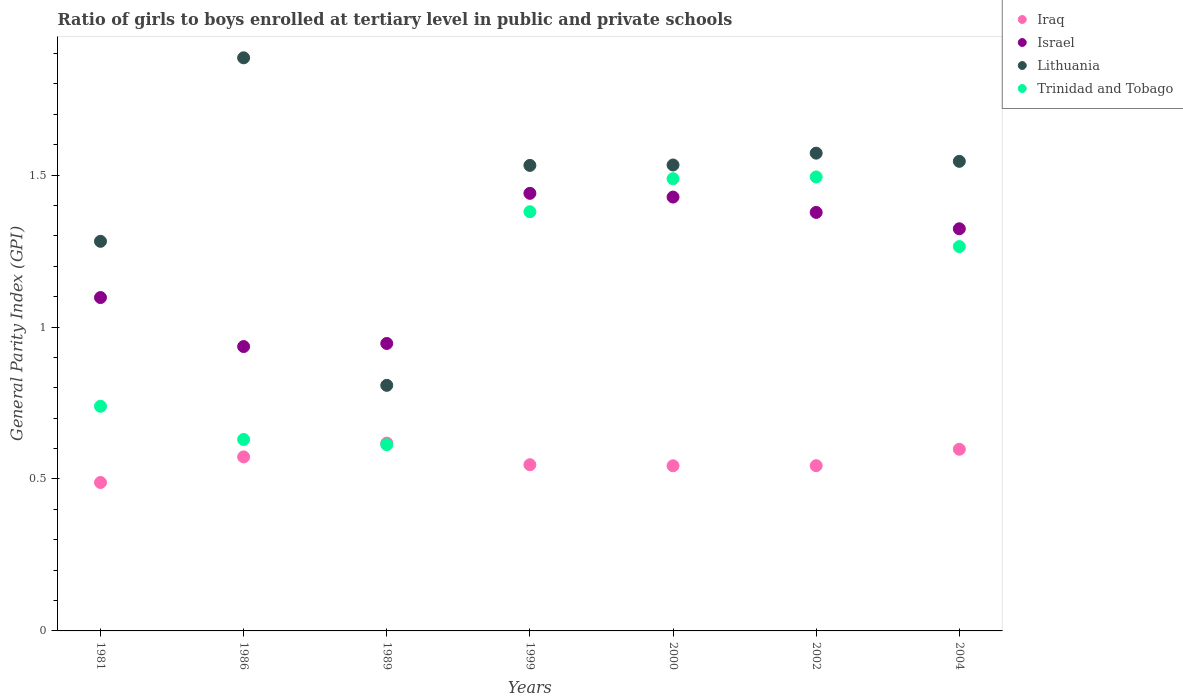What is the general parity index in Iraq in 2000?
Provide a succinct answer. 0.54. Across all years, what is the maximum general parity index in Lithuania?
Your answer should be very brief. 1.89. Across all years, what is the minimum general parity index in Trinidad and Tobago?
Your answer should be compact. 0.61. In which year was the general parity index in Trinidad and Tobago maximum?
Keep it short and to the point. 2002. What is the total general parity index in Iraq in the graph?
Keep it short and to the point. 3.91. What is the difference between the general parity index in Lithuania in 1981 and that in 2004?
Provide a short and direct response. -0.26. What is the difference between the general parity index in Israel in 2004 and the general parity index in Lithuania in 2000?
Keep it short and to the point. -0.21. What is the average general parity index in Trinidad and Tobago per year?
Provide a short and direct response. 1.09. In the year 1989, what is the difference between the general parity index in Trinidad and Tobago and general parity index in Iraq?
Keep it short and to the point. -0.01. What is the ratio of the general parity index in Israel in 2002 to that in 2004?
Your answer should be compact. 1.04. Is the general parity index in Iraq in 1999 less than that in 2002?
Offer a terse response. No. What is the difference between the highest and the second highest general parity index in Lithuania?
Give a very brief answer. 0.31. What is the difference between the highest and the lowest general parity index in Israel?
Give a very brief answer. 0.5. Is the sum of the general parity index in Lithuania in 1981 and 2000 greater than the maximum general parity index in Israel across all years?
Keep it short and to the point. Yes. Is it the case that in every year, the sum of the general parity index in Israel and general parity index in Lithuania  is greater than the general parity index in Trinidad and Tobago?
Your answer should be very brief. Yes. Is the general parity index in Iraq strictly greater than the general parity index in Lithuania over the years?
Provide a succinct answer. No. Is the general parity index in Iraq strictly less than the general parity index in Trinidad and Tobago over the years?
Give a very brief answer. No. What is the difference between two consecutive major ticks on the Y-axis?
Your answer should be very brief. 0.5. Does the graph contain any zero values?
Provide a succinct answer. No. Where does the legend appear in the graph?
Provide a succinct answer. Top right. How many legend labels are there?
Provide a succinct answer. 4. How are the legend labels stacked?
Give a very brief answer. Vertical. What is the title of the graph?
Make the answer very short. Ratio of girls to boys enrolled at tertiary level in public and private schools. Does "Channel Islands" appear as one of the legend labels in the graph?
Provide a succinct answer. No. What is the label or title of the X-axis?
Your answer should be very brief. Years. What is the label or title of the Y-axis?
Provide a short and direct response. General Parity Index (GPI). What is the General Parity Index (GPI) of Iraq in 1981?
Make the answer very short. 0.49. What is the General Parity Index (GPI) in Israel in 1981?
Give a very brief answer. 1.1. What is the General Parity Index (GPI) of Lithuania in 1981?
Offer a terse response. 1.28. What is the General Parity Index (GPI) in Trinidad and Tobago in 1981?
Keep it short and to the point. 0.74. What is the General Parity Index (GPI) of Iraq in 1986?
Offer a terse response. 0.57. What is the General Parity Index (GPI) of Israel in 1986?
Offer a terse response. 0.94. What is the General Parity Index (GPI) in Lithuania in 1986?
Keep it short and to the point. 1.89. What is the General Parity Index (GPI) in Trinidad and Tobago in 1986?
Offer a very short reply. 0.63. What is the General Parity Index (GPI) of Iraq in 1989?
Your response must be concise. 0.62. What is the General Parity Index (GPI) in Israel in 1989?
Make the answer very short. 0.95. What is the General Parity Index (GPI) of Lithuania in 1989?
Ensure brevity in your answer.  0.81. What is the General Parity Index (GPI) in Trinidad and Tobago in 1989?
Your answer should be very brief. 0.61. What is the General Parity Index (GPI) in Iraq in 1999?
Your answer should be very brief. 0.55. What is the General Parity Index (GPI) in Israel in 1999?
Your answer should be compact. 1.44. What is the General Parity Index (GPI) in Lithuania in 1999?
Provide a short and direct response. 1.53. What is the General Parity Index (GPI) in Trinidad and Tobago in 1999?
Your response must be concise. 1.38. What is the General Parity Index (GPI) in Iraq in 2000?
Provide a short and direct response. 0.54. What is the General Parity Index (GPI) in Israel in 2000?
Make the answer very short. 1.43. What is the General Parity Index (GPI) of Lithuania in 2000?
Offer a terse response. 1.53. What is the General Parity Index (GPI) of Trinidad and Tobago in 2000?
Ensure brevity in your answer.  1.49. What is the General Parity Index (GPI) in Iraq in 2002?
Provide a succinct answer. 0.54. What is the General Parity Index (GPI) in Israel in 2002?
Ensure brevity in your answer.  1.38. What is the General Parity Index (GPI) of Lithuania in 2002?
Give a very brief answer. 1.57. What is the General Parity Index (GPI) in Trinidad and Tobago in 2002?
Offer a very short reply. 1.49. What is the General Parity Index (GPI) in Iraq in 2004?
Your answer should be compact. 0.6. What is the General Parity Index (GPI) in Israel in 2004?
Your answer should be compact. 1.32. What is the General Parity Index (GPI) of Lithuania in 2004?
Give a very brief answer. 1.55. What is the General Parity Index (GPI) in Trinidad and Tobago in 2004?
Ensure brevity in your answer.  1.26. Across all years, what is the maximum General Parity Index (GPI) in Iraq?
Offer a terse response. 0.62. Across all years, what is the maximum General Parity Index (GPI) of Israel?
Your answer should be compact. 1.44. Across all years, what is the maximum General Parity Index (GPI) in Lithuania?
Your answer should be compact. 1.89. Across all years, what is the maximum General Parity Index (GPI) in Trinidad and Tobago?
Your response must be concise. 1.49. Across all years, what is the minimum General Parity Index (GPI) in Iraq?
Keep it short and to the point. 0.49. Across all years, what is the minimum General Parity Index (GPI) in Israel?
Your answer should be compact. 0.94. Across all years, what is the minimum General Parity Index (GPI) of Lithuania?
Your response must be concise. 0.81. Across all years, what is the minimum General Parity Index (GPI) in Trinidad and Tobago?
Give a very brief answer. 0.61. What is the total General Parity Index (GPI) in Iraq in the graph?
Your response must be concise. 3.91. What is the total General Parity Index (GPI) in Israel in the graph?
Give a very brief answer. 8.55. What is the total General Parity Index (GPI) of Lithuania in the graph?
Make the answer very short. 10.16. What is the total General Parity Index (GPI) of Trinidad and Tobago in the graph?
Give a very brief answer. 7.61. What is the difference between the General Parity Index (GPI) in Iraq in 1981 and that in 1986?
Your answer should be compact. -0.08. What is the difference between the General Parity Index (GPI) in Israel in 1981 and that in 1986?
Provide a succinct answer. 0.16. What is the difference between the General Parity Index (GPI) of Lithuania in 1981 and that in 1986?
Keep it short and to the point. -0.6. What is the difference between the General Parity Index (GPI) of Trinidad and Tobago in 1981 and that in 1986?
Your response must be concise. 0.11. What is the difference between the General Parity Index (GPI) of Iraq in 1981 and that in 1989?
Provide a short and direct response. -0.13. What is the difference between the General Parity Index (GPI) of Israel in 1981 and that in 1989?
Keep it short and to the point. 0.15. What is the difference between the General Parity Index (GPI) in Lithuania in 1981 and that in 1989?
Offer a terse response. 0.47. What is the difference between the General Parity Index (GPI) in Trinidad and Tobago in 1981 and that in 1989?
Give a very brief answer. 0.13. What is the difference between the General Parity Index (GPI) in Iraq in 1981 and that in 1999?
Your response must be concise. -0.06. What is the difference between the General Parity Index (GPI) of Israel in 1981 and that in 1999?
Offer a very short reply. -0.34. What is the difference between the General Parity Index (GPI) of Lithuania in 1981 and that in 1999?
Your response must be concise. -0.25. What is the difference between the General Parity Index (GPI) in Trinidad and Tobago in 1981 and that in 1999?
Make the answer very short. -0.64. What is the difference between the General Parity Index (GPI) of Iraq in 1981 and that in 2000?
Keep it short and to the point. -0.06. What is the difference between the General Parity Index (GPI) in Israel in 1981 and that in 2000?
Provide a succinct answer. -0.33. What is the difference between the General Parity Index (GPI) of Lithuania in 1981 and that in 2000?
Keep it short and to the point. -0.25. What is the difference between the General Parity Index (GPI) of Trinidad and Tobago in 1981 and that in 2000?
Your response must be concise. -0.75. What is the difference between the General Parity Index (GPI) of Iraq in 1981 and that in 2002?
Keep it short and to the point. -0.06. What is the difference between the General Parity Index (GPI) in Israel in 1981 and that in 2002?
Ensure brevity in your answer.  -0.28. What is the difference between the General Parity Index (GPI) in Lithuania in 1981 and that in 2002?
Offer a terse response. -0.29. What is the difference between the General Parity Index (GPI) of Trinidad and Tobago in 1981 and that in 2002?
Offer a very short reply. -0.75. What is the difference between the General Parity Index (GPI) in Iraq in 1981 and that in 2004?
Give a very brief answer. -0.11. What is the difference between the General Parity Index (GPI) in Israel in 1981 and that in 2004?
Give a very brief answer. -0.23. What is the difference between the General Parity Index (GPI) in Lithuania in 1981 and that in 2004?
Your answer should be compact. -0.26. What is the difference between the General Parity Index (GPI) of Trinidad and Tobago in 1981 and that in 2004?
Your answer should be very brief. -0.53. What is the difference between the General Parity Index (GPI) of Iraq in 1986 and that in 1989?
Provide a succinct answer. -0.05. What is the difference between the General Parity Index (GPI) of Israel in 1986 and that in 1989?
Ensure brevity in your answer.  -0.01. What is the difference between the General Parity Index (GPI) in Lithuania in 1986 and that in 1989?
Provide a short and direct response. 1.08. What is the difference between the General Parity Index (GPI) in Trinidad and Tobago in 1986 and that in 1989?
Your response must be concise. 0.02. What is the difference between the General Parity Index (GPI) of Iraq in 1986 and that in 1999?
Make the answer very short. 0.03. What is the difference between the General Parity Index (GPI) of Israel in 1986 and that in 1999?
Keep it short and to the point. -0.5. What is the difference between the General Parity Index (GPI) of Lithuania in 1986 and that in 1999?
Offer a terse response. 0.35. What is the difference between the General Parity Index (GPI) of Trinidad and Tobago in 1986 and that in 1999?
Offer a very short reply. -0.75. What is the difference between the General Parity Index (GPI) in Iraq in 1986 and that in 2000?
Give a very brief answer. 0.03. What is the difference between the General Parity Index (GPI) of Israel in 1986 and that in 2000?
Make the answer very short. -0.49. What is the difference between the General Parity Index (GPI) of Lithuania in 1986 and that in 2000?
Provide a short and direct response. 0.35. What is the difference between the General Parity Index (GPI) in Trinidad and Tobago in 1986 and that in 2000?
Your answer should be compact. -0.86. What is the difference between the General Parity Index (GPI) of Iraq in 1986 and that in 2002?
Your response must be concise. 0.03. What is the difference between the General Parity Index (GPI) of Israel in 1986 and that in 2002?
Make the answer very short. -0.44. What is the difference between the General Parity Index (GPI) in Lithuania in 1986 and that in 2002?
Give a very brief answer. 0.31. What is the difference between the General Parity Index (GPI) in Trinidad and Tobago in 1986 and that in 2002?
Offer a terse response. -0.86. What is the difference between the General Parity Index (GPI) of Iraq in 1986 and that in 2004?
Your answer should be very brief. -0.03. What is the difference between the General Parity Index (GPI) of Israel in 1986 and that in 2004?
Offer a terse response. -0.39. What is the difference between the General Parity Index (GPI) of Lithuania in 1986 and that in 2004?
Your response must be concise. 0.34. What is the difference between the General Parity Index (GPI) in Trinidad and Tobago in 1986 and that in 2004?
Ensure brevity in your answer.  -0.63. What is the difference between the General Parity Index (GPI) in Iraq in 1989 and that in 1999?
Your answer should be compact. 0.07. What is the difference between the General Parity Index (GPI) of Israel in 1989 and that in 1999?
Give a very brief answer. -0.49. What is the difference between the General Parity Index (GPI) of Lithuania in 1989 and that in 1999?
Your answer should be very brief. -0.72. What is the difference between the General Parity Index (GPI) in Trinidad and Tobago in 1989 and that in 1999?
Offer a very short reply. -0.77. What is the difference between the General Parity Index (GPI) of Iraq in 1989 and that in 2000?
Make the answer very short. 0.07. What is the difference between the General Parity Index (GPI) of Israel in 1989 and that in 2000?
Your answer should be compact. -0.48. What is the difference between the General Parity Index (GPI) in Lithuania in 1989 and that in 2000?
Your response must be concise. -0.72. What is the difference between the General Parity Index (GPI) of Trinidad and Tobago in 1989 and that in 2000?
Give a very brief answer. -0.88. What is the difference between the General Parity Index (GPI) of Iraq in 1989 and that in 2002?
Give a very brief answer. 0.07. What is the difference between the General Parity Index (GPI) in Israel in 1989 and that in 2002?
Ensure brevity in your answer.  -0.43. What is the difference between the General Parity Index (GPI) in Lithuania in 1989 and that in 2002?
Provide a succinct answer. -0.76. What is the difference between the General Parity Index (GPI) of Trinidad and Tobago in 1989 and that in 2002?
Give a very brief answer. -0.88. What is the difference between the General Parity Index (GPI) of Iraq in 1989 and that in 2004?
Provide a succinct answer. 0.02. What is the difference between the General Parity Index (GPI) of Israel in 1989 and that in 2004?
Keep it short and to the point. -0.38. What is the difference between the General Parity Index (GPI) of Lithuania in 1989 and that in 2004?
Your response must be concise. -0.74. What is the difference between the General Parity Index (GPI) of Trinidad and Tobago in 1989 and that in 2004?
Your response must be concise. -0.65. What is the difference between the General Parity Index (GPI) in Iraq in 1999 and that in 2000?
Provide a succinct answer. 0. What is the difference between the General Parity Index (GPI) of Israel in 1999 and that in 2000?
Offer a very short reply. 0.01. What is the difference between the General Parity Index (GPI) of Lithuania in 1999 and that in 2000?
Give a very brief answer. -0. What is the difference between the General Parity Index (GPI) in Trinidad and Tobago in 1999 and that in 2000?
Make the answer very short. -0.11. What is the difference between the General Parity Index (GPI) in Iraq in 1999 and that in 2002?
Your answer should be very brief. 0. What is the difference between the General Parity Index (GPI) of Israel in 1999 and that in 2002?
Ensure brevity in your answer.  0.06. What is the difference between the General Parity Index (GPI) of Lithuania in 1999 and that in 2002?
Your answer should be compact. -0.04. What is the difference between the General Parity Index (GPI) of Trinidad and Tobago in 1999 and that in 2002?
Offer a terse response. -0.11. What is the difference between the General Parity Index (GPI) of Iraq in 1999 and that in 2004?
Make the answer very short. -0.05. What is the difference between the General Parity Index (GPI) in Israel in 1999 and that in 2004?
Offer a very short reply. 0.12. What is the difference between the General Parity Index (GPI) in Lithuania in 1999 and that in 2004?
Give a very brief answer. -0.01. What is the difference between the General Parity Index (GPI) in Trinidad and Tobago in 1999 and that in 2004?
Offer a terse response. 0.11. What is the difference between the General Parity Index (GPI) of Iraq in 2000 and that in 2002?
Make the answer very short. -0. What is the difference between the General Parity Index (GPI) of Israel in 2000 and that in 2002?
Your answer should be very brief. 0.05. What is the difference between the General Parity Index (GPI) in Lithuania in 2000 and that in 2002?
Offer a very short reply. -0.04. What is the difference between the General Parity Index (GPI) of Trinidad and Tobago in 2000 and that in 2002?
Ensure brevity in your answer.  -0.01. What is the difference between the General Parity Index (GPI) of Iraq in 2000 and that in 2004?
Give a very brief answer. -0.05. What is the difference between the General Parity Index (GPI) of Israel in 2000 and that in 2004?
Make the answer very short. 0.1. What is the difference between the General Parity Index (GPI) in Lithuania in 2000 and that in 2004?
Your answer should be compact. -0.01. What is the difference between the General Parity Index (GPI) of Trinidad and Tobago in 2000 and that in 2004?
Provide a succinct answer. 0.22. What is the difference between the General Parity Index (GPI) of Iraq in 2002 and that in 2004?
Give a very brief answer. -0.05. What is the difference between the General Parity Index (GPI) of Israel in 2002 and that in 2004?
Ensure brevity in your answer.  0.05. What is the difference between the General Parity Index (GPI) in Lithuania in 2002 and that in 2004?
Your answer should be compact. 0.03. What is the difference between the General Parity Index (GPI) of Trinidad and Tobago in 2002 and that in 2004?
Give a very brief answer. 0.23. What is the difference between the General Parity Index (GPI) in Iraq in 1981 and the General Parity Index (GPI) in Israel in 1986?
Provide a succinct answer. -0.45. What is the difference between the General Parity Index (GPI) of Iraq in 1981 and the General Parity Index (GPI) of Lithuania in 1986?
Your answer should be compact. -1.4. What is the difference between the General Parity Index (GPI) of Iraq in 1981 and the General Parity Index (GPI) of Trinidad and Tobago in 1986?
Give a very brief answer. -0.14. What is the difference between the General Parity Index (GPI) of Israel in 1981 and the General Parity Index (GPI) of Lithuania in 1986?
Provide a short and direct response. -0.79. What is the difference between the General Parity Index (GPI) of Israel in 1981 and the General Parity Index (GPI) of Trinidad and Tobago in 1986?
Give a very brief answer. 0.47. What is the difference between the General Parity Index (GPI) in Lithuania in 1981 and the General Parity Index (GPI) in Trinidad and Tobago in 1986?
Ensure brevity in your answer.  0.65. What is the difference between the General Parity Index (GPI) in Iraq in 1981 and the General Parity Index (GPI) in Israel in 1989?
Offer a very short reply. -0.46. What is the difference between the General Parity Index (GPI) of Iraq in 1981 and the General Parity Index (GPI) of Lithuania in 1989?
Offer a terse response. -0.32. What is the difference between the General Parity Index (GPI) in Iraq in 1981 and the General Parity Index (GPI) in Trinidad and Tobago in 1989?
Provide a short and direct response. -0.12. What is the difference between the General Parity Index (GPI) in Israel in 1981 and the General Parity Index (GPI) in Lithuania in 1989?
Your answer should be very brief. 0.29. What is the difference between the General Parity Index (GPI) in Israel in 1981 and the General Parity Index (GPI) in Trinidad and Tobago in 1989?
Keep it short and to the point. 0.48. What is the difference between the General Parity Index (GPI) of Lithuania in 1981 and the General Parity Index (GPI) of Trinidad and Tobago in 1989?
Provide a succinct answer. 0.67. What is the difference between the General Parity Index (GPI) of Iraq in 1981 and the General Parity Index (GPI) of Israel in 1999?
Give a very brief answer. -0.95. What is the difference between the General Parity Index (GPI) of Iraq in 1981 and the General Parity Index (GPI) of Lithuania in 1999?
Your answer should be very brief. -1.04. What is the difference between the General Parity Index (GPI) of Iraq in 1981 and the General Parity Index (GPI) of Trinidad and Tobago in 1999?
Provide a short and direct response. -0.89. What is the difference between the General Parity Index (GPI) of Israel in 1981 and the General Parity Index (GPI) of Lithuania in 1999?
Your answer should be very brief. -0.43. What is the difference between the General Parity Index (GPI) of Israel in 1981 and the General Parity Index (GPI) of Trinidad and Tobago in 1999?
Give a very brief answer. -0.28. What is the difference between the General Parity Index (GPI) in Lithuania in 1981 and the General Parity Index (GPI) in Trinidad and Tobago in 1999?
Give a very brief answer. -0.1. What is the difference between the General Parity Index (GPI) in Iraq in 1981 and the General Parity Index (GPI) in Israel in 2000?
Provide a succinct answer. -0.94. What is the difference between the General Parity Index (GPI) of Iraq in 1981 and the General Parity Index (GPI) of Lithuania in 2000?
Your answer should be compact. -1.04. What is the difference between the General Parity Index (GPI) of Iraq in 1981 and the General Parity Index (GPI) of Trinidad and Tobago in 2000?
Ensure brevity in your answer.  -1. What is the difference between the General Parity Index (GPI) in Israel in 1981 and the General Parity Index (GPI) in Lithuania in 2000?
Provide a succinct answer. -0.44. What is the difference between the General Parity Index (GPI) in Israel in 1981 and the General Parity Index (GPI) in Trinidad and Tobago in 2000?
Make the answer very short. -0.39. What is the difference between the General Parity Index (GPI) in Lithuania in 1981 and the General Parity Index (GPI) in Trinidad and Tobago in 2000?
Ensure brevity in your answer.  -0.21. What is the difference between the General Parity Index (GPI) of Iraq in 1981 and the General Parity Index (GPI) of Israel in 2002?
Offer a very short reply. -0.89. What is the difference between the General Parity Index (GPI) in Iraq in 1981 and the General Parity Index (GPI) in Lithuania in 2002?
Provide a short and direct response. -1.08. What is the difference between the General Parity Index (GPI) of Iraq in 1981 and the General Parity Index (GPI) of Trinidad and Tobago in 2002?
Provide a short and direct response. -1.01. What is the difference between the General Parity Index (GPI) of Israel in 1981 and the General Parity Index (GPI) of Lithuania in 2002?
Make the answer very short. -0.48. What is the difference between the General Parity Index (GPI) of Israel in 1981 and the General Parity Index (GPI) of Trinidad and Tobago in 2002?
Offer a very short reply. -0.4. What is the difference between the General Parity Index (GPI) in Lithuania in 1981 and the General Parity Index (GPI) in Trinidad and Tobago in 2002?
Keep it short and to the point. -0.21. What is the difference between the General Parity Index (GPI) in Iraq in 1981 and the General Parity Index (GPI) in Israel in 2004?
Your response must be concise. -0.83. What is the difference between the General Parity Index (GPI) in Iraq in 1981 and the General Parity Index (GPI) in Lithuania in 2004?
Provide a succinct answer. -1.06. What is the difference between the General Parity Index (GPI) in Iraq in 1981 and the General Parity Index (GPI) in Trinidad and Tobago in 2004?
Ensure brevity in your answer.  -0.78. What is the difference between the General Parity Index (GPI) of Israel in 1981 and the General Parity Index (GPI) of Lithuania in 2004?
Offer a very short reply. -0.45. What is the difference between the General Parity Index (GPI) of Israel in 1981 and the General Parity Index (GPI) of Trinidad and Tobago in 2004?
Provide a short and direct response. -0.17. What is the difference between the General Parity Index (GPI) in Lithuania in 1981 and the General Parity Index (GPI) in Trinidad and Tobago in 2004?
Offer a very short reply. 0.02. What is the difference between the General Parity Index (GPI) of Iraq in 1986 and the General Parity Index (GPI) of Israel in 1989?
Offer a terse response. -0.37. What is the difference between the General Parity Index (GPI) in Iraq in 1986 and the General Parity Index (GPI) in Lithuania in 1989?
Make the answer very short. -0.24. What is the difference between the General Parity Index (GPI) in Iraq in 1986 and the General Parity Index (GPI) in Trinidad and Tobago in 1989?
Give a very brief answer. -0.04. What is the difference between the General Parity Index (GPI) of Israel in 1986 and the General Parity Index (GPI) of Lithuania in 1989?
Make the answer very short. 0.13. What is the difference between the General Parity Index (GPI) of Israel in 1986 and the General Parity Index (GPI) of Trinidad and Tobago in 1989?
Keep it short and to the point. 0.32. What is the difference between the General Parity Index (GPI) in Lithuania in 1986 and the General Parity Index (GPI) in Trinidad and Tobago in 1989?
Provide a short and direct response. 1.27. What is the difference between the General Parity Index (GPI) of Iraq in 1986 and the General Parity Index (GPI) of Israel in 1999?
Ensure brevity in your answer.  -0.87. What is the difference between the General Parity Index (GPI) of Iraq in 1986 and the General Parity Index (GPI) of Lithuania in 1999?
Keep it short and to the point. -0.96. What is the difference between the General Parity Index (GPI) of Iraq in 1986 and the General Parity Index (GPI) of Trinidad and Tobago in 1999?
Make the answer very short. -0.81. What is the difference between the General Parity Index (GPI) in Israel in 1986 and the General Parity Index (GPI) in Lithuania in 1999?
Provide a succinct answer. -0.6. What is the difference between the General Parity Index (GPI) in Israel in 1986 and the General Parity Index (GPI) in Trinidad and Tobago in 1999?
Your answer should be compact. -0.44. What is the difference between the General Parity Index (GPI) of Lithuania in 1986 and the General Parity Index (GPI) of Trinidad and Tobago in 1999?
Your answer should be very brief. 0.51. What is the difference between the General Parity Index (GPI) of Iraq in 1986 and the General Parity Index (GPI) of Israel in 2000?
Provide a succinct answer. -0.85. What is the difference between the General Parity Index (GPI) in Iraq in 1986 and the General Parity Index (GPI) in Lithuania in 2000?
Provide a succinct answer. -0.96. What is the difference between the General Parity Index (GPI) of Iraq in 1986 and the General Parity Index (GPI) of Trinidad and Tobago in 2000?
Give a very brief answer. -0.92. What is the difference between the General Parity Index (GPI) in Israel in 1986 and the General Parity Index (GPI) in Lithuania in 2000?
Provide a short and direct response. -0.6. What is the difference between the General Parity Index (GPI) of Israel in 1986 and the General Parity Index (GPI) of Trinidad and Tobago in 2000?
Your response must be concise. -0.55. What is the difference between the General Parity Index (GPI) in Lithuania in 1986 and the General Parity Index (GPI) in Trinidad and Tobago in 2000?
Your answer should be very brief. 0.4. What is the difference between the General Parity Index (GPI) in Iraq in 1986 and the General Parity Index (GPI) in Israel in 2002?
Make the answer very short. -0.8. What is the difference between the General Parity Index (GPI) in Iraq in 1986 and the General Parity Index (GPI) in Lithuania in 2002?
Offer a terse response. -1. What is the difference between the General Parity Index (GPI) in Iraq in 1986 and the General Parity Index (GPI) in Trinidad and Tobago in 2002?
Offer a terse response. -0.92. What is the difference between the General Parity Index (GPI) of Israel in 1986 and the General Parity Index (GPI) of Lithuania in 2002?
Provide a short and direct response. -0.64. What is the difference between the General Parity Index (GPI) of Israel in 1986 and the General Parity Index (GPI) of Trinidad and Tobago in 2002?
Offer a terse response. -0.56. What is the difference between the General Parity Index (GPI) of Lithuania in 1986 and the General Parity Index (GPI) of Trinidad and Tobago in 2002?
Your answer should be compact. 0.39. What is the difference between the General Parity Index (GPI) of Iraq in 1986 and the General Parity Index (GPI) of Israel in 2004?
Make the answer very short. -0.75. What is the difference between the General Parity Index (GPI) in Iraq in 1986 and the General Parity Index (GPI) in Lithuania in 2004?
Your response must be concise. -0.97. What is the difference between the General Parity Index (GPI) in Iraq in 1986 and the General Parity Index (GPI) in Trinidad and Tobago in 2004?
Provide a succinct answer. -0.69. What is the difference between the General Parity Index (GPI) of Israel in 1986 and the General Parity Index (GPI) of Lithuania in 2004?
Keep it short and to the point. -0.61. What is the difference between the General Parity Index (GPI) in Israel in 1986 and the General Parity Index (GPI) in Trinidad and Tobago in 2004?
Provide a succinct answer. -0.33. What is the difference between the General Parity Index (GPI) in Lithuania in 1986 and the General Parity Index (GPI) in Trinidad and Tobago in 2004?
Your answer should be compact. 0.62. What is the difference between the General Parity Index (GPI) in Iraq in 1989 and the General Parity Index (GPI) in Israel in 1999?
Ensure brevity in your answer.  -0.82. What is the difference between the General Parity Index (GPI) in Iraq in 1989 and the General Parity Index (GPI) in Lithuania in 1999?
Provide a short and direct response. -0.91. What is the difference between the General Parity Index (GPI) in Iraq in 1989 and the General Parity Index (GPI) in Trinidad and Tobago in 1999?
Your response must be concise. -0.76. What is the difference between the General Parity Index (GPI) in Israel in 1989 and the General Parity Index (GPI) in Lithuania in 1999?
Ensure brevity in your answer.  -0.59. What is the difference between the General Parity Index (GPI) of Israel in 1989 and the General Parity Index (GPI) of Trinidad and Tobago in 1999?
Your answer should be compact. -0.43. What is the difference between the General Parity Index (GPI) in Lithuania in 1989 and the General Parity Index (GPI) in Trinidad and Tobago in 1999?
Your response must be concise. -0.57. What is the difference between the General Parity Index (GPI) of Iraq in 1989 and the General Parity Index (GPI) of Israel in 2000?
Your answer should be compact. -0.81. What is the difference between the General Parity Index (GPI) in Iraq in 1989 and the General Parity Index (GPI) in Lithuania in 2000?
Your response must be concise. -0.92. What is the difference between the General Parity Index (GPI) of Iraq in 1989 and the General Parity Index (GPI) of Trinidad and Tobago in 2000?
Give a very brief answer. -0.87. What is the difference between the General Parity Index (GPI) of Israel in 1989 and the General Parity Index (GPI) of Lithuania in 2000?
Give a very brief answer. -0.59. What is the difference between the General Parity Index (GPI) of Israel in 1989 and the General Parity Index (GPI) of Trinidad and Tobago in 2000?
Offer a very short reply. -0.54. What is the difference between the General Parity Index (GPI) of Lithuania in 1989 and the General Parity Index (GPI) of Trinidad and Tobago in 2000?
Ensure brevity in your answer.  -0.68. What is the difference between the General Parity Index (GPI) of Iraq in 1989 and the General Parity Index (GPI) of Israel in 2002?
Your response must be concise. -0.76. What is the difference between the General Parity Index (GPI) of Iraq in 1989 and the General Parity Index (GPI) of Lithuania in 2002?
Keep it short and to the point. -0.95. What is the difference between the General Parity Index (GPI) in Iraq in 1989 and the General Parity Index (GPI) in Trinidad and Tobago in 2002?
Offer a very short reply. -0.88. What is the difference between the General Parity Index (GPI) of Israel in 1989 and the General Parity Index (GPI) of Lithuania in 2002?
Provide a succinct answer. -0.63. What is the difference between the General Parity Index (GPI) of Israel in 1989 and the General Parity Index (GPI) of Trinidad and Tobago in 2002?
Offer a very short reply. -0.55. What is the difference between the General Parity Index (GPI) in Lithuania in 1989 and the General Parity Index (GPI) in Trinidad and Tobago in 2002?
Offer a very short reply. -0.69. What is the difference between the General Parity Index (GPI) in Iraq in 1989 and the General Parity Index (GPI) in Israel in 2004?
Offer a terse response. -0.71. What is the difference between the General Parity Index (GPI) in Iraq in 1989 and the General Parity Index (GPI) in Lithuania in 2004?
Offer a terse response. -0.93. What is the difference between the General Parity Index (GPI) in Iraq in 1989 and the General Parity Index (GPI) in Trinidad and Tobago in 2004?
Ensure brevity in your answer.  -0.65. What is the difference between the General Parity Index (GPI) of Israel in 1989 and the General Parity Index (GPI) of Lithuania in 2004?
Give a very brief answer. -0.6. What is the difference between the General Parity Index (GPI) of Israel in 1989 and the General Parity Index (GPI) of Trinidad and Tobago in 2004?
Your response must be concise. -0.32. What is the difference between the General Parity Index (GPI) in Lithuania in 1989 and the General Parity Index (GPI) in Trinidad and Tobago in 2004?
Offer a very short reply. -0.46. What is the difference between the General Parity Index (GPI) of Iraq in 1999 and the General Parity Index (GPI) of Israel in 2000?
Make the answer very short. -0.88. What is the difference between the General Parity Index (GPI) in Iraq in 1999 and the General Parity Index (GPI) in Lithuania in 2000?
Offer a terse response. -0.99. What is the difference between the General Parity Index (GPI) of Iraq in 1999 and the General Parity Index (GPI) of Trinidad and Tobago in 2000?
Your response must be concise. -0.94. What is the difference between the General Parity Index (GPI) in Israel in 1999 and the General Parity Index (GPI) in Lithuania in 2000?
Your answer should be very brief. -0.09. What is the difference between the General Parity Index (GPI) of Israel in 1999 and the General Parity Index (GPI) of Trinidad and Tobago in 2000?
Offer a very short reply. -0.05. What is the difference between the General Parity Index (GPI) of Lithuania in 1999 and the General Parity Index (GPI) of Trinidad and Tobago in 2000?
Give a very brief answer. 0.04. What is the difference between the General Parity Index (GPI) of Iraq in 1999 and the General Parity Index (GPI) of Israel in 2002?
Give a very brief answer. -0.83. What is the difference between the General Parity Index (GPI) of Iraq in 1999 and the General Parity Index (GPI) of Lithuania in 2002?
Give a very brief answer. -1.03. What is the difference between the General Parity Index (GPI) of Iraq in 1999 and the General Parity Index (GPI) of Trinidad and Tobago in 2002?
Ensure brevity in your answer.  -0.95. What is the difference between the General Parity Index (GPI) in Israel in 1999 and the General Parity Index (GPI) in Lithuania in 2002?
Make the answer very short. -0.13. What is the difference between the General Parity Index (GPI) in Israel in 1999 and the General Parity Index (GPI) in Trinidad and Tobago in 2002?
Your answer should be compact. -0.05. What is the difference between the General Parity Index (GPI) of Lithuania in 1999 and the General Parity Index (GPI) of Trinidad and Tobago in 2002?
Give a very brief answer. 0.04. What is the difference between the General Parity Index (GPI) of Iraq in 1999 and the General Parity Index (GPI) of Israel in 2004?
Offer a terse response. -0.78. What is the difference between the General Parity Index (GPI) of Iraq in 1999 and the General Parity Index (GPI) of Lithuania in 2004?
Offer a terse response. -1. What is the difference between the General Parity Index (GPI) of Iraq in 1999 and the General Parity Index (GPI) of Trinidad and Tobago in 2004?
Your answer should be very brief. -0.72. What is the difference between the General Parity Index (GPI) in Israel in 1999 and the General Parity Index (GPI) in Lithuania in 2004?
Keep it short and to the point. -0.11. What is the difference between the General Parity Index (GPI) of Israel in 1999 and the General Parity Index (GPI) of Trinidad and Tobago in 2004?
Your answer should be very brief. 0.18. What is the difference between the General Parity Index (GPI) of Lithuania in 1999 and the General Parity Index (GPI) of Trinidad and Tobago in 2004?
Make the answer very short. 0.27. What is the difference between the General Parity Index (GPI) of Iraq in 2000 and the General Parity Index (GPI) of Israel in 2002?
Provide a short and direct response. -0.83. What is the difference between the General Parity Index (GPI) of Iraq in 2000 and the General Parity Index (GPI) of Lithuania in 2002?
Provide a short and direct response. -1.03. What is the difference between the General Parity Index (GPI) of Iraq in 2000 and the General Parity Index (GPI) of Trinidad and Tobago in 2002?
Offer a very short reply. -0.95. What is the difference between the General Parity Index (GPI) of Israel in 2000 and the General Parity Index (GPI) of Lithuania in 2002?
Give a very brief answer. -0.14. What is the difference between the General Parity Index (GPI) in Israel in 2000 and the General Parity Index (GPI) in Trinidad and Tobago in 2002?
Your answer should be very brief. -0.07. What is the difference between the General Parity Index (GPI) in Lithuania in 2000 and the General Parity Index (GPI) in Trinidad and Tobago in 2002?
Keep it short and to the point. 0.04. What is the difference between the General Parity Index (GPI) in Iraq in 2000 and the General Parity Index (GPI) in Israel in 2004?
Offer a very short reply. -0.78. What is the difference between the General Parity Index (GPI) in Iraq in 2000 and the General Parity Index (GPI) in Lithuania in 2004?
Keep it short and to the point. -1. What is the difference between the General Parity Index (GPI) in Iraq in 2000 and the General Parity Index (GPI) in Trinidad and Tobago in 2004?
Your answer should be compact. -0.72. What is the difference between the General Parity Index (GPI) in Israel in 2000 and the General Parity Index (GPI) in Lithuania in 2004?
Offer a very short reply. -0.12. What is the difference between the General Parity Index (GPI) in Israel in 2000 and the General Parity Index (GPI) in Trinidad and Tobago in 2004?
Provide a short and direct response. 0.16. What is the difference between the General Parity Index (GPI) of Lithuania in 2000 and the General Parity Index (GPI) of Trinidad and Tobago in 2004?
Provide a succinct answer. 0.27. What is the difference between the General Parity Index (GPI) in Iraq in 2002 and the General Parity Index (GPI) in Israel in 2004?
Provide a succinct answer. -0.78. What is the difference between the General Parity Index (GPI) of Iraq in 2002 and the General Parity Index (GPI) of Lithuania in 2004?
Provide a succinct answer. -1. What is the difference between the General Parity Index (GPI) in Iraq in 2002 and the General Parity Index (GPI) in Trinidad and Tobago in 2004?
Ensure brevity in your answer.  -0.72. What is the difference between the General Parity Index (GPI) in Israel in 2002 and the General Parity Index (GPI) in Lithuania in 2004?
Ensure brevity in your answer.  -0.17. What is the difference between the General Parity Index (GPI) of Israel in 2002 and the General Parity Index (GPI) of Trinidad and Tobago in 2004?
Your answer should be very brief. 0.11. What is the difference between the General Parity Index (GPI) of Lithuania in 2002 and the General Parity Index (GPI) of Trinidad and Tobago in 2004?
Provide a succinct answer. 0.31. What is the average General Parity Index (GPI) of Iraq per year?
Give a very brief answer. 0.56. What is the average General Parity Index (GPI) in Israel per year?
Make the answer very short. 1.22. What is the average General Parity Index (GPI) in Lithuania per year?
Provide a succinct answer. 1.45. What is the average General Parity Index (GPI) in Trinidad and Tobago per year?
Give a very brief answer. 1.09. In the year 1981, what is the difference between the General Parity Index (GPI) of Iraq and General Parity Index (GPI) of Israel?
Provide a succinct answer. -0.61. In the year 1981, what is the difference between the General Parity Index (GPI) in Iraq and General Parity Index (GPI) in Lithuania?
Your response must be concise. -0.79. In the year 1981, what is the difference between the General Parity Index (GPI) of Iraq and General Parity Index (GPI) of Trinidad and Tobago?
Ensure brevity in your answer.  -0.25. In the year 1981, what is the difference between the General Parity Index (GPI) of Israel and General Parity Index (GPI) of Lithuania?
Your response must be concise. -0.18. In the year 1981, what is the difference between the General Parity Index (GPI) of Israel and General Parity Index (GPI) of Trinidad and Tobago?
Provide a succinct answer. 0.36. In the year 1981, what is the difference between the General Parity Index (GPI) of Lithuania and General Parity Index (GPI) of Trinidad and Tobago?
Offer a very short reply. 0.54. In the year 1986, what is the difference between the General Parity Index (GPI) of Iraq and General Parity Index (GPI) of Israel?
Ensure brevity in your answer.  -0.36. In the year 1986, what is the difference between the General Parity Index (GPI) of Iraq and General Parity Index (GPI) of Lithuania?
Your response must be concise. -1.31. In the year 1986, what is the difference between the General Parity Index (GPI) in Iraq and General Parity Index (GPI) in Trinidad and Tobago?
Offer a very short reply. -0.06. In the year 1986, what is the difference between the General Parity Index (GPI) of Israel and General Parity Index (GPI) of Lithuania?
Your answer should be very brief. -0.95. In the year 1986, what is the difference between the General Parity Index (GPI) in Israel and General Parity Index (GPI) in Trinidad and Tobago?
Keep it short and to the point. 0.31. In the year 1986, what is the difference between the General Parity Index (GPI) of Lithuania and General Parity Index (GPI) of Trinidad and Tobago?
Keep it short and to the point. 1.26. In the year 1989, what is the difference between the General Parity Index (GPI) of Iraq and General Parity Index (GPI) of Israel?
Ensure brevity in your answer.  -0.33. In the year 1989, what is the difference between the General Parity Index (GPI) in Iraq and General Parity Index (GPI) in Lithuania?
Your response must be concise. -0.19. In the year 1989, what is the difference between the General Parity Index (GPI) of Iraq and General Parity Index (GPI) of Trinidad and Tobago?
Your answer should be very brief. 0.01. In the year 1989, what is the difference between the General Parity Index (GPI) in Israel and General Parity Index (GPI) in Lithuania?
Keep it short and to the point. 0.14. In the year 1989, what is the difference between the General Parity Index (GPI) of Israel and General Parity Index (GPI) of Trinidad and Tobago?
Keep it short and to the point. 0.33. In the year 1989, what is the difference between the General Parity Index (GPI) of Lithuania and General Parity Index (GPI) of Trinidad and Tobago?
Offer a very short reply. 0.2. In the year 1999, what is the difference between the General Parity Index (GPI) in Iraq and General Parity Index (GPI) in Israel?
Your response must be concise. -0.89. In the year 1999, what is the difference between the General Parity Index (GPI) of Iraq and General Parity Index (GPI) of Lithuania?
Offer a terse response. -0.98. In the year 1999, what is the difference between the General Parity Index (GPI) of Iraq and General Parity Index (GPI) of Trinidad and Tobago?
Make the answer very short. -0.83. In the year 1999, what is the difference between the General Parity Index (GPI) of Israel and General Parity Index (GPI) of Lithuania?
Keep it short and to the point. -0.09. In the year 1999, what is the difference between the General Parity Index (GPI) of Israel and General Parity Index (GPI) of Trinidad and Tobago?
Ensure brevity in your answer.  0.06. In the year 1999, what is the difference between the General Parity Index (GPI) in Lithuania and General Parity Index (GPI) in Trinidad and Tobago?
Keep it short and to the point. 0.15. In the year 2000, what is the difference between the General Parity Index (GPI) of Iraq and General Parity Index (GPI) of Israel?
Your answer should be compact. -0.88. In the year 2000, what is the difference between the General Parity Index (GPI) in Iraq and General Parity Index (GPI) in Lithuania?
Provide a succinct answer. -0.99. In the year 2000, what is the difference between the General Parity Index (GPI) in Iraq and General Parity Index (GPI) in Trinidad and Tobago?
Provide a succinct answer. -0.94. In the year 2000, what is the difference between the General Parity Index (GPI) of Israel and General Parity Index (GPI) of Lithuania?
Your response must be concise. -0.11. In the year 2000, what is the difference between the General Parity Index (GPI) of Israel and General Parity Index (GPI) of Trinidad and Tobago?
Make the answer very short. -0.06. In the year 2000, what is the difference between the General Parity Index (GPI) of Lithuania and General Parity Index (GPI) of Trinidad and Tobago?
Provide a succinct answer. 0.05. In the year 2002, what is the difference between the General Parity Index (GPI) in Iraq and General Parity Index (GPI) in Israel?
Ensure brevity in your answer.  -0.83. In the year 2002, what is the difference between the General Parity Index (GPI) of Iraq and General Parity Index (GPI) of Lithuania?
Make the answer very short. -1.03. In the year 2002, what is the difference between the General Parity Index (GPI) of Iraq and General Parity Index (GPI) of Trinidad and Tobago?
Your answer should be very brief. -0.95. In the year 2002, what is the difference between the General Parity Index (GPI) of Israel and General Parity Index (GPI) of Lithuania?
Provide a succinct answer. -0.19. In the year 2002, what is the difference between the General Parity Index (GPI) in Israel and General Parity Index (GPI) in Trinidad and Tobago?
Ensure brevity in your answer.  -0.12. In the year 2002, what is the difference between the General Parity Index (GPI) in Lithuania and General Parity Index (GPI) in Trinidad and Tobago?
Your answer should be very brief. 0.08. In the year 2004, what is the difference between the General Parity Index (GPI) in Iraq and General Parity Index (GPI) in Israel?
Make the answer very short. -0.73. In the year 2004, what is the difference between the General Parity Index (GPI) of Iraq and General Parity Index (GPI) of Lithuania?
Ensure brevity in your answer.  -0.95. In the year 2004, what is the difference between the General Parity Index (GPI) of Iraq and General Parity Index (GPI) of Trinidad and Tobago?
Give a very brief answer. -0.67. In the year 2004, what is the difference between the General Parity Index (GPI) of Israel and General Parity Index (GPI) of Lithuania?
Give a very brief answer. -0.22. In the year 2004, what is the difference between the General Parity Index (GPI) of Israel and General Parity Index (GPI) of Trinidad and Tobago?
Your answer should be very brief. 0.06. In the year 2004, what is the difference between the General Parity Index (GPI) in Lithuania and General Parity Index (GPI) in Trinidad and Tobago?
Your answer should be very brief. 0.28. What is the ratio of the General Parity Index (GPI) in Iraq in 1981 to that in 1986?
Your answer should be very brief. 0.85. What is the ratio of the General Parity Index (GPI) of Israel in 1981 to that in 1986?
Ensure brevity in your answer.  1.17. What is the ratio of the General Parity Index (GPI) of Lithuania in 1981 to that in 1986?
Your answer should be compact. 0.68. What is the ratio of the General Parity Index (GPI) of Trinidad and Tobago in 1981 to that in 1986?
Your answer should be compact. 1.17. What is the ratio of the General Parity Index (GPI) in Iraq in 1981 to that in 1989?
Provide a succinct answer. 0.79. What is the ratio of the General Parity Index (GPI) of Israel in 1981 to that in 1989?
Keep it short and to the point. 1.16. What is the ratio of the General Parity Index (GPI) of Lithuania in 1981 to that in 1989?
Provide a short and direct response. 1.59. What is the ratio of the General Parity Index (GPI) in Trinidad and Tobago in 1981 to that in 1989?
Provide a short and direct response. 1.21. What is the ratio of the General Parity Index (GPI) in Iraq in 1981 to that in 1999?
Make the answer very short. 0.89. What is the ratio of the General Parity Index (GPI) of Israel in 1981 to that in 1999?
Offer a very short reply. 0.76. What is the ratio of the General Parity Index (GPI) of Lithuania in 1981 to that in 1999?
Your answer should be very brief. 0.84. What is the ratio of the General Parity Index (GPI) of Trinidad and Tobago in 1981 to that in 1999?
Make the answer very short. 0.54. What is the ratio of the General Parity Index (GPI) in Iraq in 1981 to that in 2000?
Provide a short and direct response. 0.9. What is the ratio of the General Parity Index (GPI) of Israel in 1981 to that in 2000?
Ensure brevity in your answer.  0.77. What is the ratio of the General Parity Index (GPI) in Lithuania in 1981 to that in 2000?
Offer a very short reply. 0.84. What is the ratio of the General Parity Index (GPI) in Trinidad and Tobago in 1981 to that in 2000?
Provide a short and direct response. 0.5. What is the ratio of the General Parity Index (GPI) of Iraq in 1981 to that in 2002?
Your answer should be very brief. 0.9. What is the ratio of the General Parity Index (GPI) in Israel in 1981 to that in 2002?
Offer a terse response. 0.8. What is the ratio of the General Parity Index (GPI) in Lithuania in 1981 to that in 2002?
Provide a succinct answer. 0.82. What is the ratio of the General Parity Index (GPI) of Trinidad and Tobago in 1981 to that in 2002?
Offer a terse response. 0.49. What is the ratio of the General Parity Index (GPI) in Iraq in 1981 to that in 2004?
Provide a short and direct response. 0.82. What is the ratio of the General Parity Index (GPI) in Israel in 1981 to that in 2004?
Keep it short and to the point. 0.83. What is the ratio of the General Parity Index (GPI) in Lithuania in 1981 to that in 2004?
Ensure brevity in your answer.  0.83. What is the ratio of the General Parity Index (GPI) of Trinidad and Tobago in 1981 to that in 2004?
Your answer should be compact. 0.58. What is the ratio of the General Parity Index (GPI) of Iraq in 1986 to that in 1989?
Offer a very short reply. 0.93. What is the ratio of the General Parity Index (GPI) in Israel in 1986 to that in 1989?
Keep it short and to the point. 0.99. What is the ratio of the General Parity Index (GPI) of Lithuania in 1986 to that in 1989?
Offer a terse response. 2.33. What is the ratio of the General Parity Index (GPI) in Trinidad and Tobago in 1986 to that in 1989?
Your response must be concise. 1.03. What is the ratio of the General Parity Index (GPI) of Iraq in 1986 to that in 1999?
Offer a terse response. 1.05. What is the ratio of the General Parity Index (GPI) of Israel in 1986 to that in 1999?
Provide a short and direct response. 0.65. What is the ratio of the General Parity Index (GPI) in Lithuania in 1986 to that in 1999?
Offer a terse response. 1.23. What is the ratio of the General Parity Index (GPI) of Trinidad and Tobago in 1986 to that in 1999?
Make the answer very short. 0.46. What is the ratio of the General Parity Index (GPI) of Iraq in 1986 to that in 2000?
Make the answer very short. 1.05. What is the ratio of the General Parity Index (GPI) of Israel in 1986 to that in 2000?
Provide a succinct answer. 0.66. What is the ratio of the General Parity Index (GPI) of Lithuania in 1986 to that in 2000?
Offer a terse response. 1.23. What is the ratio of the General Parity Index (GPI) of Trinidad and Tobago in 1986 to that in 2000?
Provide a short and direct response. 0.42. What is the ratio of the General Parity Index (GPI) in Iraq in 1986 to that in 2002?
Provide a short and direct response. 1.05. What is the ratio of the General Parity Index (GPI) of Israel in 1986 to that in 2002?
Make the answer very short. 0.68. What is the ratio of the General Parity Index (GPI) of Lithuania in 1986 to that in 2002?
Your answer should be compact. 1.2. What is the ratio of the General Parity Index (GPI) in Trinidad and Tobago in 1986 to that in 2002?
Provide a succinct answer. 0.42. What is the ratio of the General Parity Index (GPI) in Iraq in 1986 to that in 2004?
Provide a succinct answer. 0.96. What is the ratio of the General Parity Index (GPI) of Israel in 1986 to that in 2004?
Your answer should be compact. 0.71. What is the ratio of the General Parity Index (GPI) of Lithuania in 1986 to that in 2004?
Keep it short and to the point. 1.22. What is the ratio of the General Parity Index (GPI) of Trinidad and Tobago in 1986 to that in 2004?
Give a very brief answer. 0.5. What is the ratio of the General Parity Index (GPI) of Iraq in 1989 to that in 1999?
Make the answer very short. 1.13. What is the ratio of the General Parity Index (GPI) in Israel in 1989 to that in 1999?
Your response must be concise. 0.66. What is the ratio of the General Parity Index (GPI) in Lithuania in 1989 to that in 1999?
Offer a very short reply. 0.53. What is the ratio of the General Parity Index (GPI) of Trinidad and Tobago in 1989 to that in 1999?
Give a very brief answer. 0.44. What is the ratio of the General Parity Index (GPI) in Iraq in 1989 to that in 2000?
Provide a short and direct response. 1.14. What is the ratio of the General Parity Index (GPI) in Israel in 1989 to that in 2000?
Offer a very short reply. 0.66. What is the ratio of the General Parity Index (GPI) of Lithuania in 1989 to that in 2000?
Offer a terse response. 0.53. What is the ratio of the General Parity Index (GPI) in Trinidad and Tobago in 1989 to that in 2000?
Your response must be concise. 0.41. What is the ratio of the General Parity Index (GPI) in Iraq in 1989 to that in 2002?
Offer a terse response. 1.14. What is the ratio of the General Parity Index (GPI) of Israel in 1989 to that in 2002?
Your answer should be compact. 0.69. What is the ratio of the General Parity Index (GPI) in Lithuania in 1989 to that in 2002?
Your answer should be very brief. 0.51. What is the ratio of the General Parity Index (GPI) in Trinidad and Tobago in 1989 to that in 2002?
Ensure brevity in your answer.  0.41. What is the ratio of the General Parity Index (GPI) in Iraq in 1989 to that in 2004?
Give a very brief answer. 1.03. What is the ratio of the General Parity Index (GPI) of Israel in 1989 to that in 2004?
Keep it short and to the point. 0.71. What is the ratio of the General Parity Index (GPI) of Lithuania in 1989 to that in 2004?
Offer a very short reply. 0.52. What is the ratio of the General Parity Index (GPI) in Trinidad and Tobago in 1989 to that in 2004?
Provide a short and direct response. 0.48. What is the ratio of the General Parity Index (GPI) in Iraq in 1999 to that in 2000?
Your response must be concise. 1.01. What is the ratio of the General Parity Index (GPI) of Israel in 1999 to that in 2000?
Keep it short and to the point. 1.01. What is the ratio of the General Parity Index (GPI) of Trinidad and Tobago in 1999 to that in 2000?
Offer a very short reply. 0.93. What is the ratio of the General Parity Index (GPI) of Iraq in 1999 to that in 2002?
Ensure brevity in your answer.  1.01. What is the ratio of the General Parity Index (GPI) in Israel in 1999 to that in 2002?
Make the answer very short. 1.05. What is the ratio of the General Parity Index (GPI) in Lithuania in 1999 to that in 2002?
Provide a succinct answer. 0.97. What is the ratio of the General Parity Index (GPI) in Trinidad and Tobago in 1999 to that in 2002?
Ensure brevity in your answer.  0.92. What is the ratio of the General Parity Index (GPI) of Iraq in 1999 to that in 2004?
Provide a succinct answer. 0.91. What is the ratio of the General Parity Index (GPI) of Israel in 1999 to that in 2004?
Ensure brevity in your answer.  1.09. What is the ratio of the General Parity Index (GPI) of Lithuania in 1999 to that in 2004?
Ensure brevity in your answer.  0.99. What is the ratio of the General Parity Index (GPI) in Trinidad and Tobago in 1999 to that in 2004?
Make the answer very short. 1.09. What is the ratio of the General Parity Index (GPI) of Iraq in 2000 to that in 2002?
Your answer should be very brief. 1. What is the ratio of the General Parity Index (GPI) in Israel in 2000 to that in 2002?
Provide a succinct answer. 1.04. What is the ratio of the General Parity Index (GPI) in Lithuania in 2000 to that in 2002?
Provide a short and direct response. 0.98. What is the ratio of the General Parity Index (GPI) in Iraq in 2000 to that in 2004?
Provide a succinct answer. 0.91. What is the ratio of the General Parity Index (GPI) of Israel in 2000 to that in 2004?
Give a very brief answer. 1.08. What is the ratio of the General Parity Index (GPI) of Trinidad and Tobago in 2000 to that in 2004?
Make the answer very short. 1.18. What is the ratio of the General Parity Index (GPI) in Iraq in 2002 to that in 2004?
Keep it short and to the point. 0.91. What is the ratio of the General Parity Index (GPI) in Israel in 2002 to that in 2004?
Keep it short and to the point. 1.04. What is the ratio of the General Parity Index (GPI) of Lithuania in 2002 to that in 2004?
Provide a succinct answer. 1.02. What is the ratio of the General Parity Index (GPI) of Trinidad and Tobago in 2002 to that in 2004?
Your answer should be compact. 1.18. What is the difference between the highest and the second highest General Parity Index (GPI) of Iraq?
Keep it short and to the point. 0.02. What is the difference between the highest and the second highest General Parity Index (GPI) in Israel?
Your answer should be very brief. 0.01. What is the difference between the highest and the second highest General Parity Index (GPI) in Lithuania?
Your answer should be compact. 0.31. What is the difference between the highest and the second highest General Parity Index (GPI) of Trinidad and Tobago?
Keep it short and to the point. 0.01. What is the difference between the highest and the lowest General Parity Index (GPI) in Iraq?
Ensure brevity in your answer.  0.13. What is the difference between the highest and the lowest General Parity Index (GPI) of Israel?
Offer a terse response. 0.5. What is the difference between the highest and the lowest General Parity Index (GPI) in Lithuania?
Make the answer very short. 1.08. What is the difference between the highest and the lowest General Parity Index (GPI) of Trinidad and Tobago?
Give a very brief answer. 0.88. 